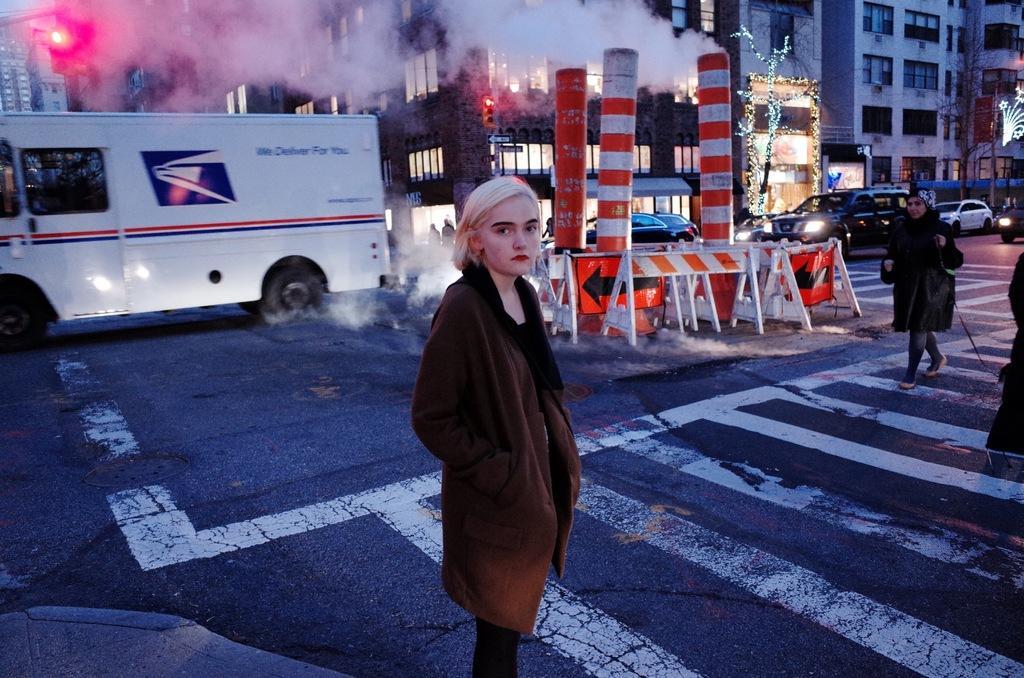Can you describe this image briefly? In this picture we can see a woman is standing on the road. Behind the woman, there is a vehicle, barricades, buildings, smoke and there are poles with traffic signals. On the right side of the image, there are vehicles, a tree and a person is walking on the road. 